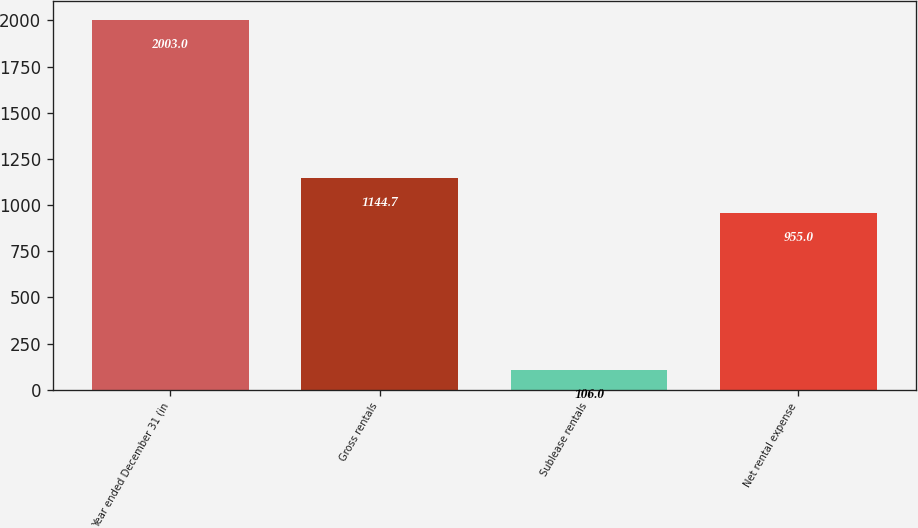Convert chart. <chart><loc_0><loc_0><loc_500><loc_500><bar_chart><fcel>Year ended December 31 (in<fcel>Gross rentals<fcel>Sublease rentals<fcel>Net rental expense<nl><fcel>2003<fcel>1144.7<fcel>106<fcel>955<nl></chart> 